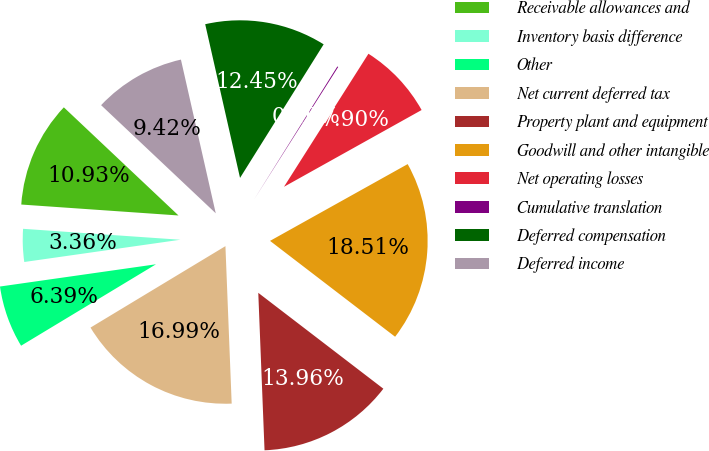Convert chart to OTSL. <chart><loc_0><loc_0><loc_500><loc_500><pie_chart><fcel>Receivable allowances and<fcel>Inventory basis difference<fcel>Other<fcel>Net current deferred tax<fcel>Property plant and equipment<fcel>Goodwill and other intangible<fcel>Net operating losses<fcel>Cumulative translation<fcel>Deferred compensation<fcel>Deferred income<nl><fcel>10.93%<fcel>3.36%<fcel>6.39%<fcel>16.99%<fcel>13.96%<fcel>18.51%<fcel>7.9%<fcel>0.1%<fcel>12.45%<fcel>9.42%<nl></chart> 